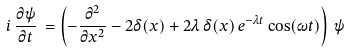Convert formula to latex. <formula><loc_0><loc_0><loc_500><loc_500>i \, \frac { \partial \psi } { \partial t } \, = \left ( - \frac { \partial ^ { 2 } } { \partial x ^ { 2 } } - 2 \delta ( x ) + 2 \lambda \, \delta ( x ) \, e ^ { - \lambda t } \cos ( \omega t ) \right ) \, \psi</formula> 